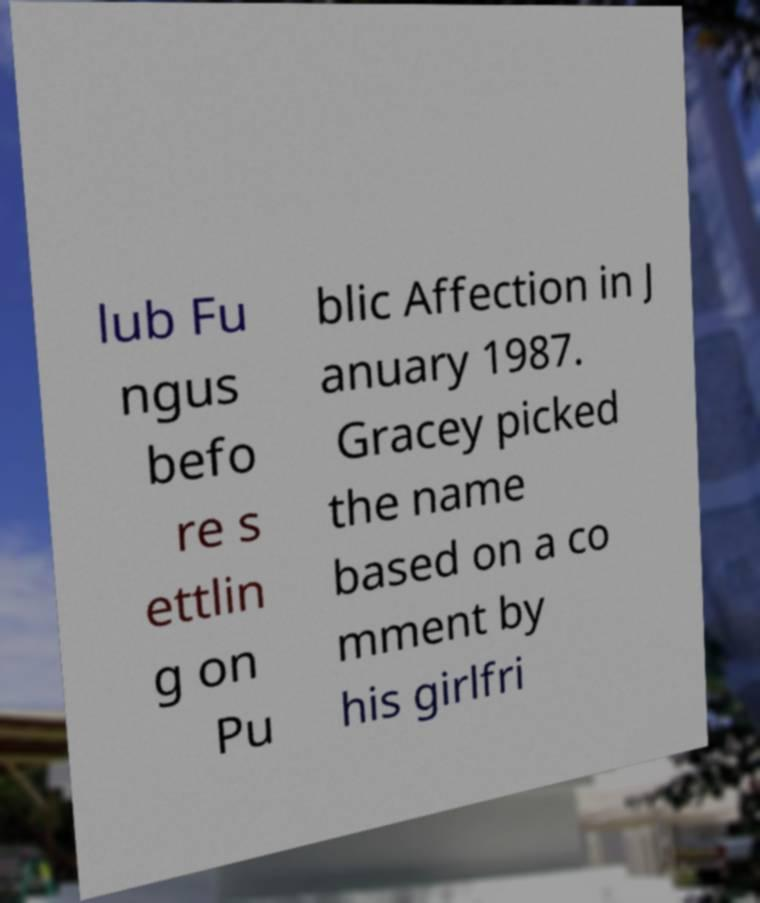Could you extract and type out the text from this image? lub Fu ngus befo re s ettlin g on Pu blic Affection in J anuary 1987. Gracey picked the name based on a co mment by his girlfri 